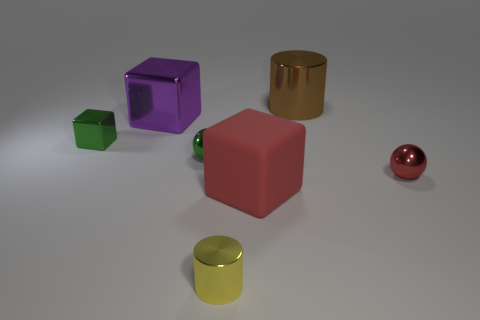What is the material of the thing that is to the right of the small yellow cylinder and behind the small red ball? metal 